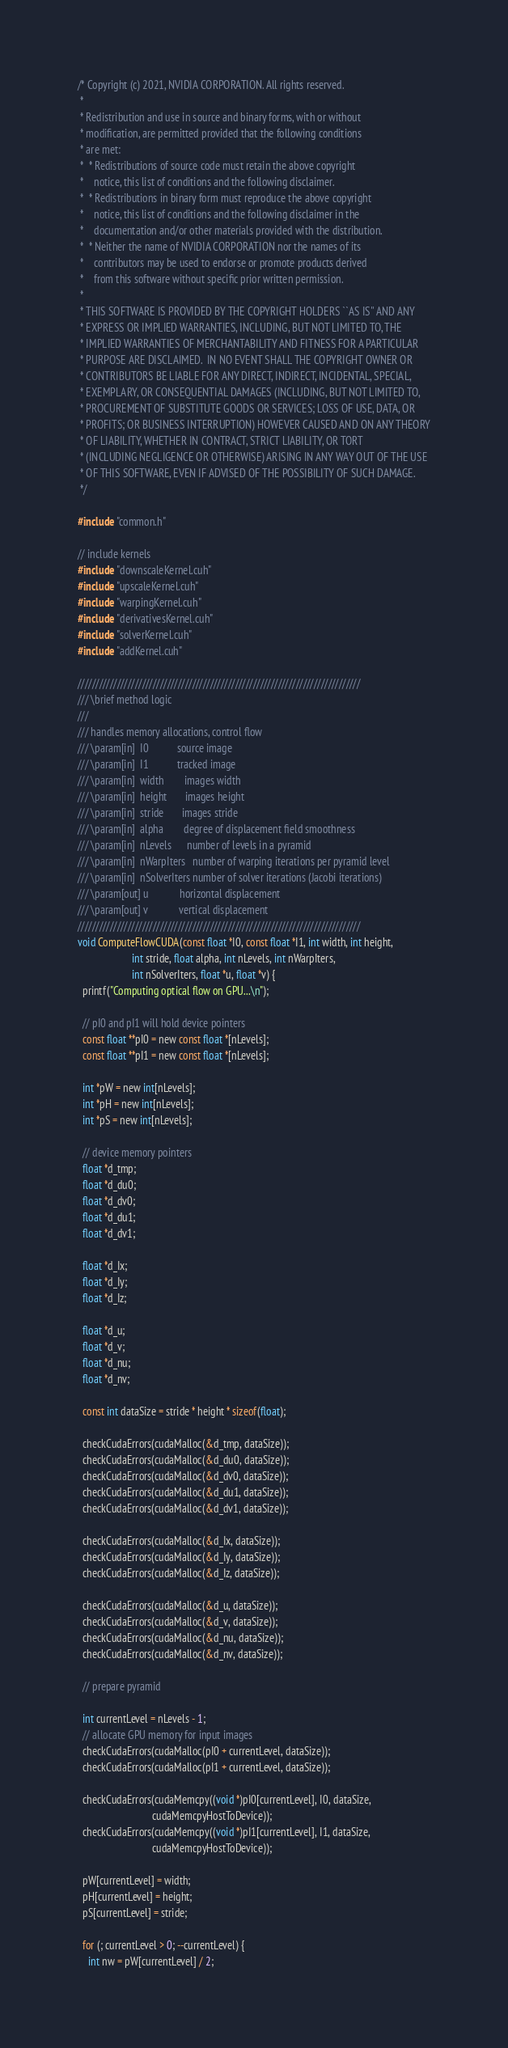Convert code to text. <code><loc_0><loc_0><loc_500><loc_500><_Cuda_>/* Copyright (c) 2021, NVIDIA CORPORATION. All rights reserved.
 *
 * Redistribution and use in source and binary forms, with or without
 * modification, are permitted provided that the following conditions
 * are met:
 *  * Redistributions of source code must retain the above copyright
 *    notice, this list of conditions and the following disclaimer.
 *  * Redistributions in binary form must reproduce the above copyright
 *    notice, this list of conditions and the following disclaimer in the
 *    documentation and/or other materials provided with the distribution.
 *  * Neither the name of NVIDIA CORPORATION nor the names of its
 *    contributors may be used to endorse or promote products derived
 *    from this software without specific prior written permission.
 *
 * THIS SOFTWARE IS PROVIDED BY THE COPYRIGHT HOLDERS ``AS IS'' AND ANY
 * EXPRESS OR IMPLIED WARRANTIES, INCLUDING, BUT NOT LIMITED TO, THE
 * IMPLIED WARRANTIES OF MERCHANTABILITY AND FITNESS FOR A PARTICULAR
 * PURPOSE ARE DISCLAIMED.  IN NO EVENT SHALL THE COPYRIGHT OWNER OR
 * CONTRIBUTORS BE LIABLE FOR ANY DIRECT, INDIRECT, INCIDENTAL, SPECIAL,
 * EXEMPLARY, OR CONSEQUENTIAL DAMAGES (INCLUDING, BUT NOT LIMITED TO,
 * PROCUREMENT OF SUBSTITUTE GOODS OR SERVICES; LOSS OF USE, DATA, OR
 * PROFITS; OR BUSINESS INTERRUPTION) HOWEVER CAUSED AND ON ANY THEORY
 * OF LIABILITY, WHETHER IN CONTRACT, STRICT LIABILITY, OR TORT
 * (INCLUDING NEGLIGENCE OR OTHERWISE) ARISING IN ANY WAY OUT OF THE USE
 * OF THIS SOFTWARE, EVEN IF ADVISED OF THE POSSIBILITY OF SUCH DAMAGE.
 */

#include "common.h"

// include kernels
#include "downscaleKernel.cuh"
#include "upscaleKernel.cuh"
#include "warpingKernel.cuh"
#include "derivativesKernel.cuh"
#include "solverKernel.cuh"
#include "addKernel.cuh"

///////////////////////////////////////////////////////////////////////////////
/// \brief method logic
///
/// handles memory allocations, control flow
/// \param[in]  I0           source image
/// \param[in]  I1           tracked image
/// \param[in]  width        images width
/// \param[in]  height       images height
/// \param[in]  stride       images stride
/// \param[in]  alpha        degree of displacement field smoothness
/// \param[in]  nLevels      number of levels in a pyramid
/// \param[in]  nWarpIters   number of warping iterations per pyramid level
/// \param[in]  nSolverIters number of solver iterations (Jacobi iterations)
/// \param[out] u            horizontal displacement
/// \param[out] v            vertical displacement
///////////////////////////////////////////////////////////////////////////////
void ComputeFlowCUDA(const float *I0, const float *I1, int width, int height,
                     int stride, float alpha, int nLevels, int nWarpIters,
                     int nSolverIters, float *u, float *v) {
  printf("Computing optical flow on GPU...\n");

  // pI0 and pI1 will hold device pointers
  const float **pI0 = new const float *[nLevels];
  const float **pI1 = new const float *[nLevels];

  int *pW = new int[nLevels];
  int *pH = new int[nLevels];
  int *pS = new int[nLevels];

  // device memory pointers
  float *d_tmp;
  float *d_du0;
  float *d_dv0;
  float *d_du1;
  float *d_dv1;

  float *d_Ix;
  float *d_Iy;
  float *d_Iz;

  float *d_u;
  float *d_v;
  float *d_nu;
  float *d_nv;

  const int dataSize = stride * height * sizeof(float);

  checkCudaErrors(cudaMalloc(&d_tmp, dataSize));
  checkCudaErrors(cudaMalloc(&d_du0, dataSize));
  checkCudaErrors(cudaMalloc(&d_dv0, dataSize));
  checkCudaErrors(cudaMalloc(&d_du1, dataSize));
  checkCudaErrors(cudaMalloc(&d_dv1, dataSize));

  checkCudaErrors(cudaMalloc(&d_Ix, dataSize));
  checkCudaErrors(cudaMalloc(&d_Iy, dataSize));
  checkCudaErrors(cudaMalloc(&d_Iz, dataSize));

  checkCudaErrors(cudaMalloc(&d_u, dataSize));
  checkCudaErrors(cudaMalloc(&d_v, dataSize));
  checkCudaErrors(cudaMalloc(&d_nu, dataSize));
  checkCudaErrors(cudaMalloc(&d_nv, dataSize));

  // prepare pyramid

  int currentLevel = nLevels - 1;
  // allocate GPU memory for input images
  checkCudaErrors(cudaMalloc(pI0 + currentLevel, dataSize));
  checkCudaErrors(cudaMalloc(pI1 + currentLevel, dataSize));

  checkCudaErrors(cudaMemcpy((void *)pI0[currentLevel], I0, dataSize,
                             cudaMemcpyHostToDevice));
  checkCudaErrors(cudaMemcpy((void *)pI1[currentLevel], I1, dataSize,
                             cudaMemcpyHostToDevice));

  pW[currentLevel] = width;
  pH[currentLevel] = height;
  pS[currentLevel] = stride;

  for (; currentLevel > 0; --currentLevel) {
    int nw = pW[currentLevel] / 2;</code> 